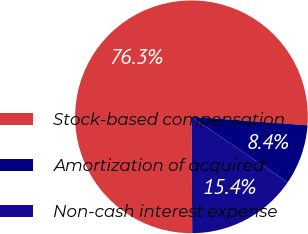Convert chart. <chart><loc_0><loc_0><loc_500><loc_500><pie_chart><fcel>Stock-based compensation<fcel>Amortization of acquired<fcel>Non-cash interest expense<nl><fcel>76.26%<fcel>8.37%<fcel>15.37%<nl></chart> 